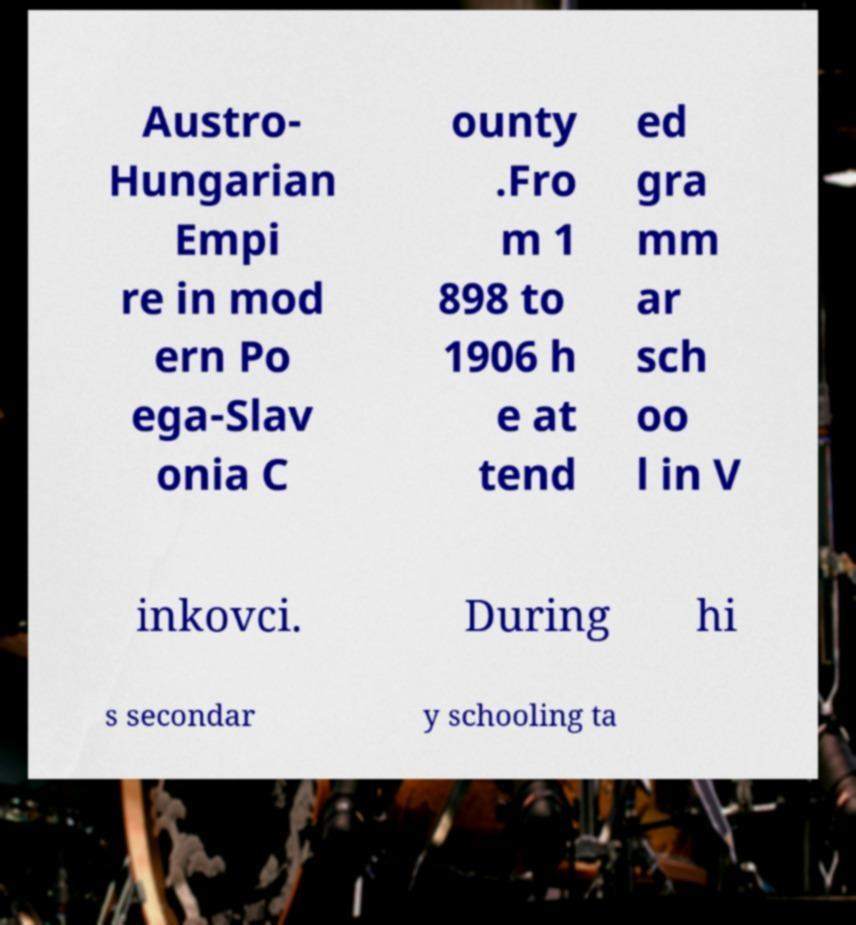Can you read and provide the text displayed in the image?This photo seems to have some interesting text. Can you extract and type it out for me? Austro- Hungarian Empi re in mod ern Po ega-Slav onia C ounty .Fro m 1 898 to 1906 h e at tend ed gra mm ar sch oo l in V inkovci. During hi s secondar y schooling ta 